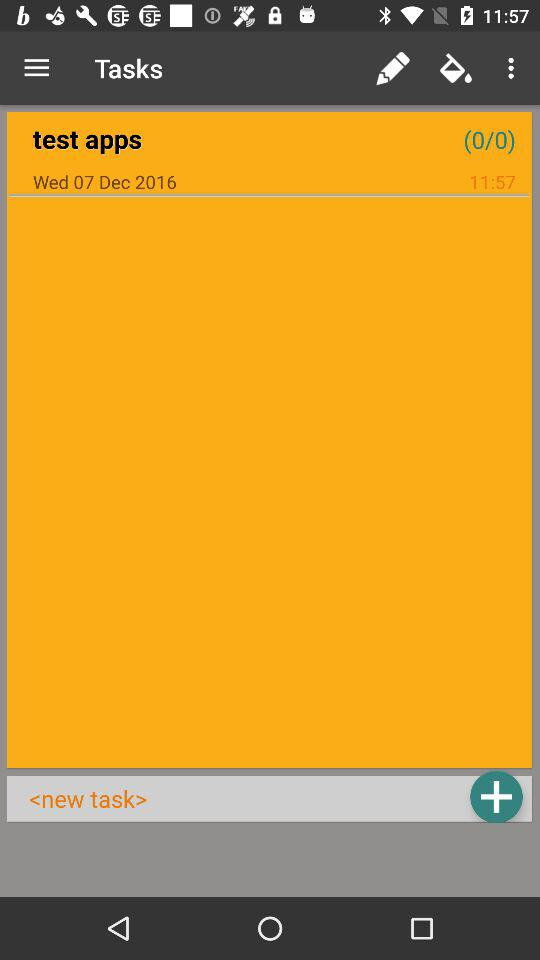What is the time? The time is 11:57. 